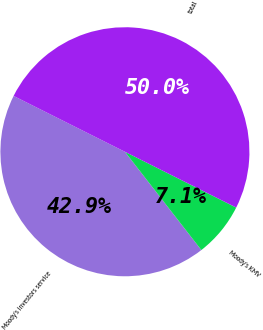Convert chart to OTSL. <chart><loc_0><loc_0><loc_500><loc_500><pie_chart><fcel>Moody's investors service<fcel>Moody's KMV<fcel>total<nl><fcel>42.92%<fcel>7.08%<fcel>50.0%<nl></chart> 